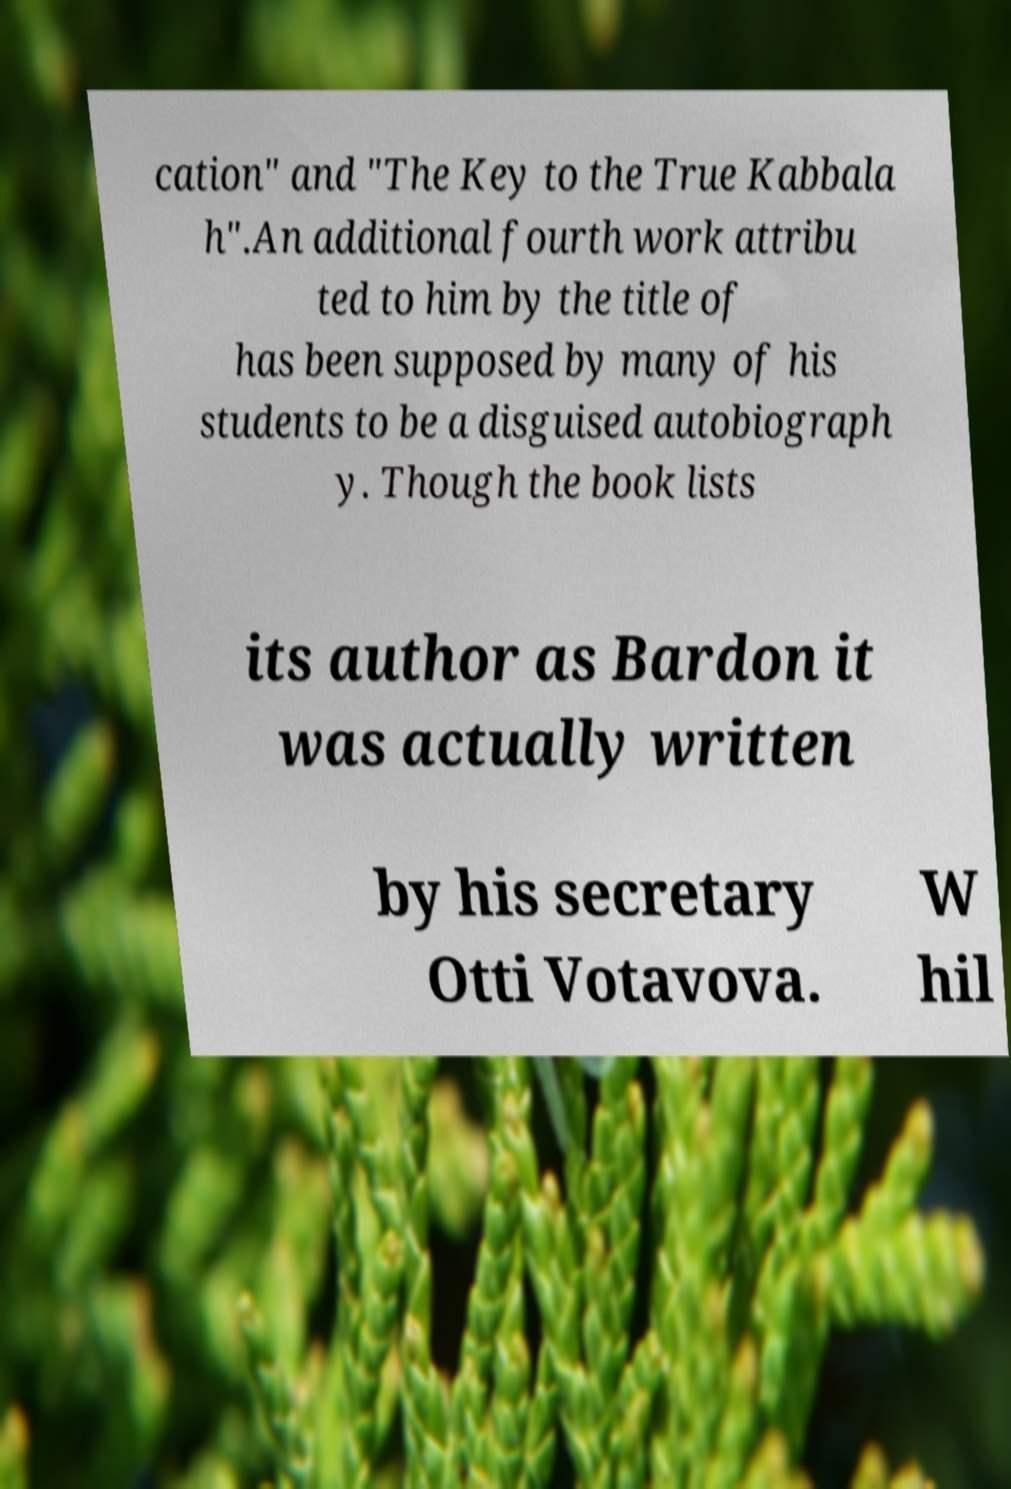Please read and relay the text visible in this image. What does it say? cation" and "The Key to the True Kabbala h".An additional fourth work attribu ted to him by the title of has been supposed by many of his students to be a disguised autobiograph y. Though the book lists its author as Bardon it was actually written by his secretary Otti Votavova. W hil 